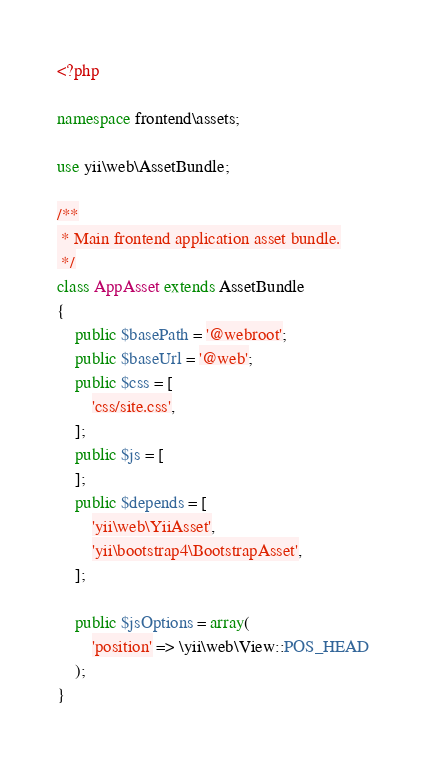<code> <loc_0><loc_0><loc_500><loc_500><_PHP_><?php

namespace frontend\assets;

use yii\web\AssetBundle;

/**
 * Main frontend application asset bundle.
 */
class AppAsset extends AssetBundle
{
    public $basePath = '@webroot';
    public $baseUrl = '@web';
    public $css = [
        'css/site.css',
    ];
    public $js = [
    ];
    public $depends = [
        'yii\web\YiiAsset',
        'yii\bootstrap4\BootstrapAsset',
    ];

    public $jsOptions = array(
        'position' => \yii\web\View::POS_HEAD
    );
}
</code> 